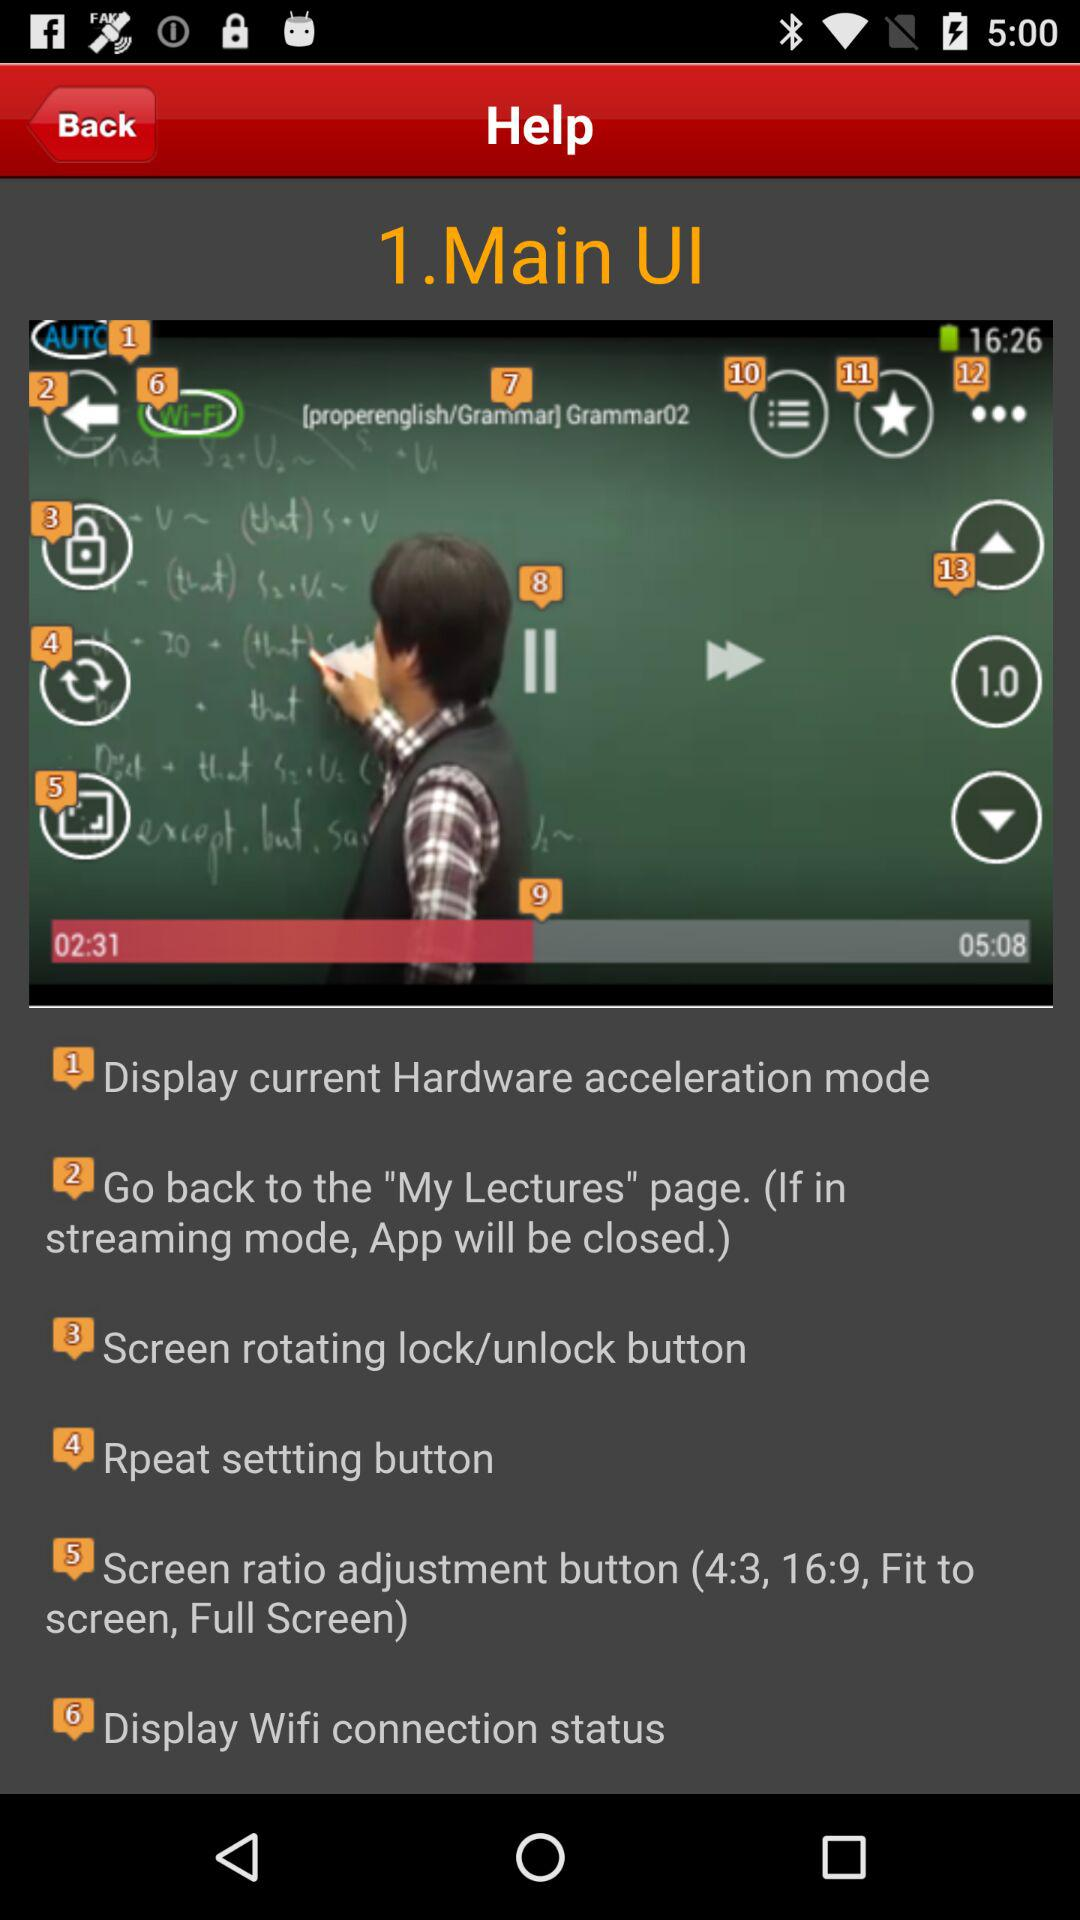What option is given for screen ratio adjustment? The options are "4:3", "16:9", "Fit to screen" and "Full Screen". 